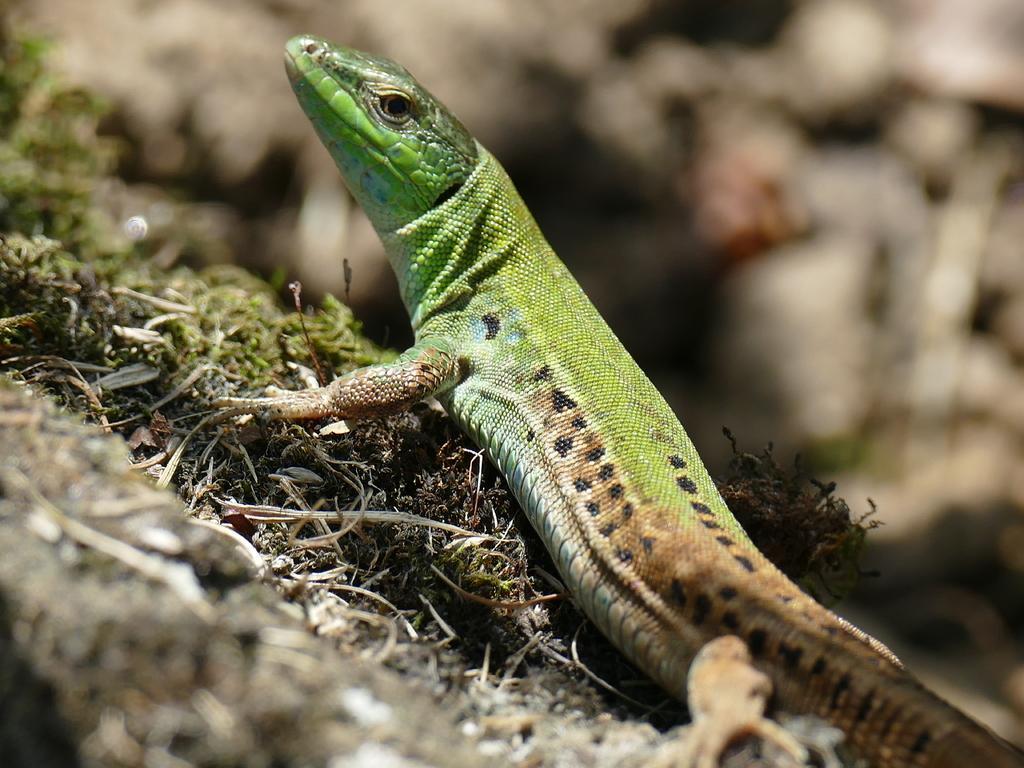In one or two sentences, can you explain what this image depicts? In this image we can see a green and brown color lizard. In the background it is blur. 